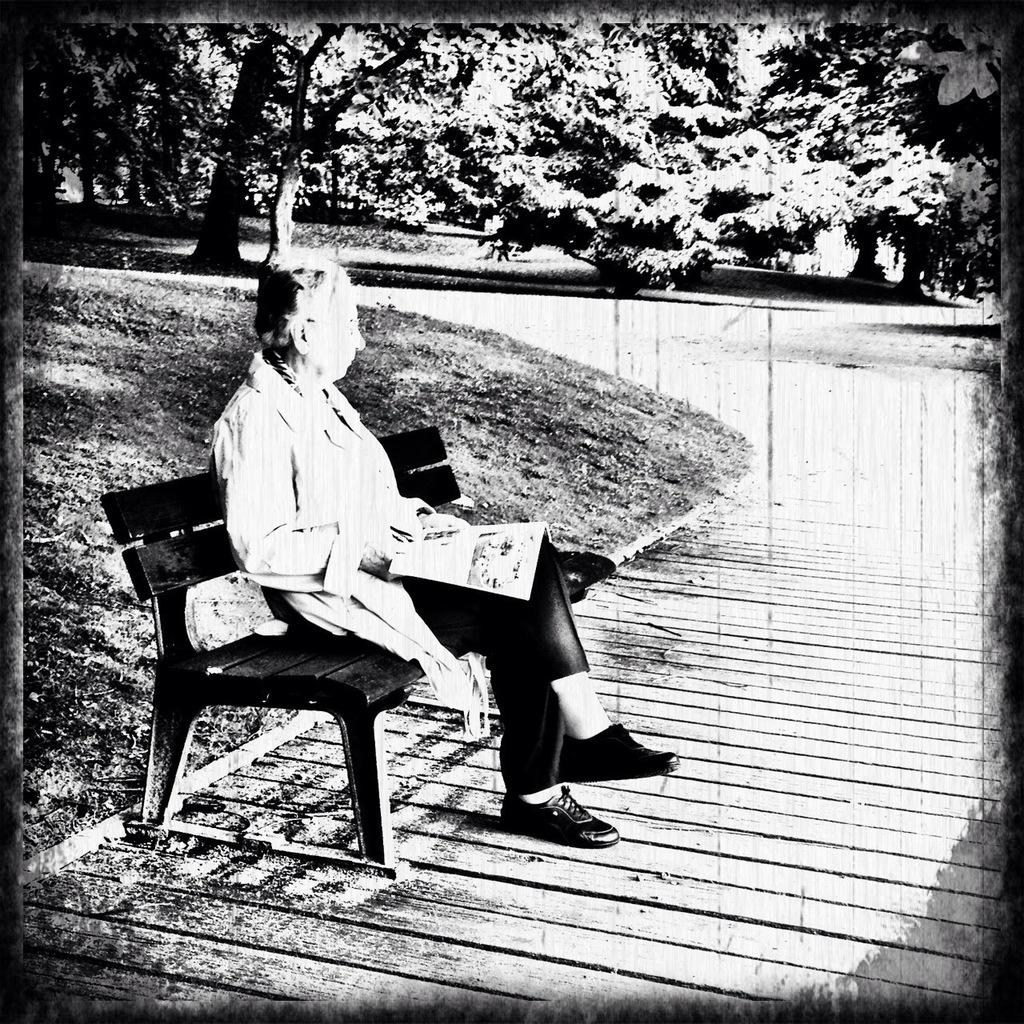What is the color scheme of the image? The image is black and white. What is the person in the image doing? The person is sitting on a bench in the image. What is the person holding in his hand? The person is holding a book in his hand. What can be seen in the background of the image? There is a land path and trees in the background of the image. What type of soda is the person drinking in the image? There is no soda present in the image; the person is holding a book. Are there any toys visible in the image? There are no toys visible in the image; the person is sitting on a bench and holding a book. 